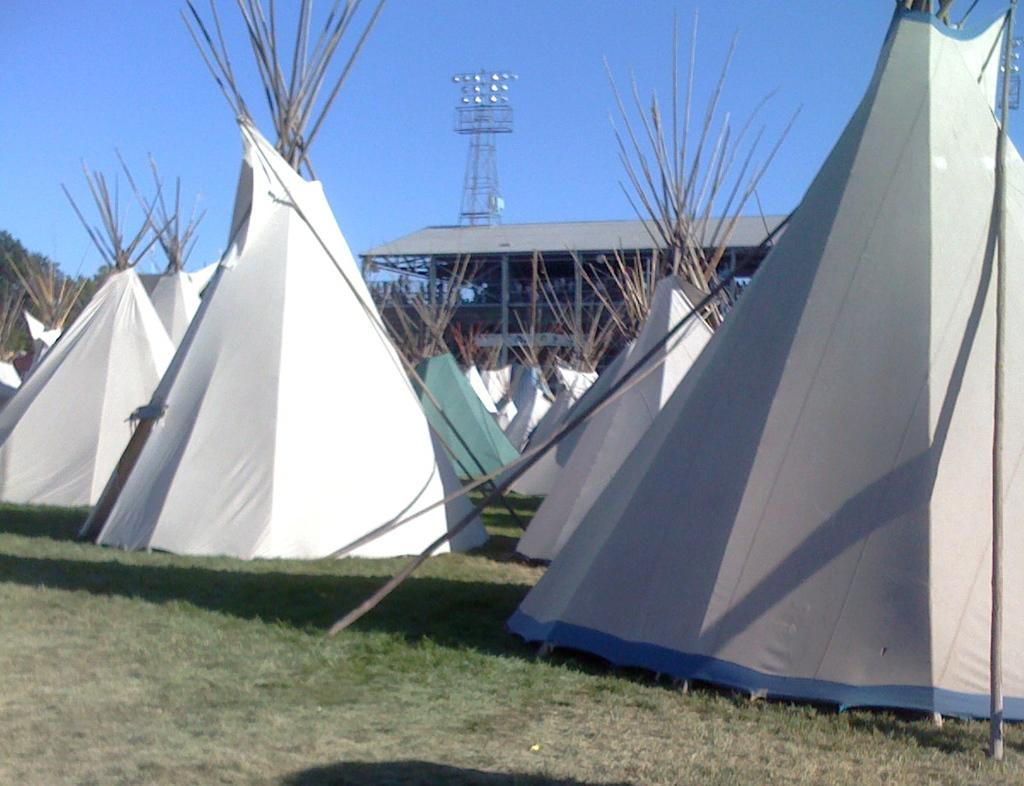What structures are located in the center of the image? There are tents in the center of the image. What type of ground surface is visible at the bottom of the image? There is grass at the bottom of the image. What type of vegetation can be seen in the image? There are trees in the image. Reasoning: Let's think step by following the guidelines to produce the conversation. We start by identifying the main subject in the image, which are the tents. Then, we expand the conversation to include other elements that are also visible, such as the grass and trees. Each question is designed to elicit a specific detail about the image that is known from the provided facts. Absurd Question/Answer: What type of spy equipment can be seen in the image? There is no spy equipment present in the image. What type of wood is used to build the tents in the image? The image does not provide information about the materials used to build the tents. What type of cloud formation can be seen in the image? There is no cloud formation present in the image. 